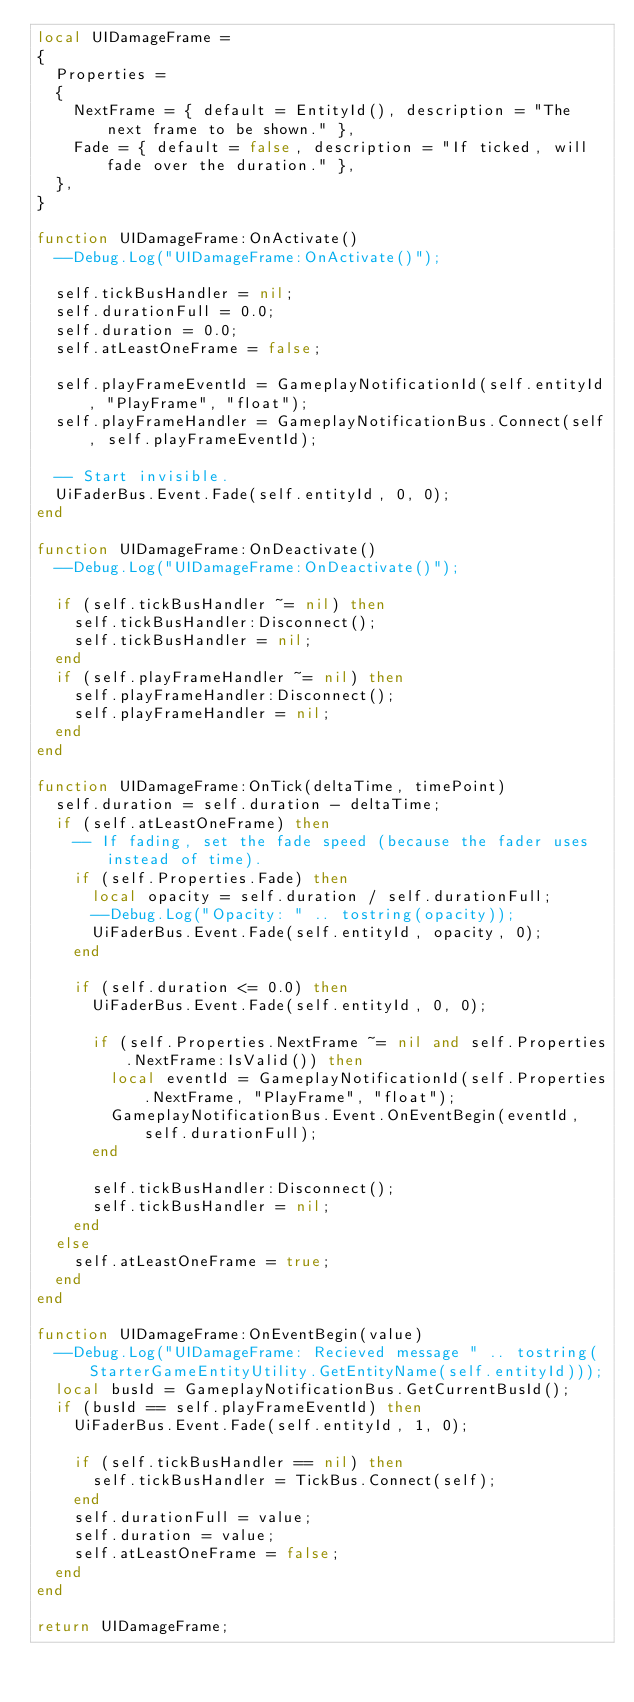Convert code to text. <code><loc_0><loc_0><loc_500><loc_500><_Lua_>local UIDamageFrame =
{
	Properties =
	{
		NextFrame = { default = EntityId(), description = "The next frame to be shown." },
		Fade = { default = false, description = "If ticked, will fade over the duration." },
	},
}

function UIDamageFrame:OnActivate()
	--Debug.Log("UIDamageFrame:OnActivate()");
	
	self.tickBusHandler = nil;
	self.durationFull = 0.0;
	self.duration = 0.0;
	self.atLeastOneFrame = false;
	
	self.playFrameEventId = GameplayNotificationId(self.entityId, "PlayFrame", "float");
	self.playFrameHandler = GameplayNotificationBus.Connect(self, self.playFrameEventId);
	
	-- Start invisible.
	UiFaderBus.Event.Fade(self.entityId, 0, 0);
end

function UIDamageFrame:OnDeactivate()
	--Debug.Log("UIDamageFrame:OnDeactivate()");
	
	if (self.tickBusHandler ~= nil) then
		self.tickBusHandler:Disconnect();
		self.tickBusHandler = nil;
	end
	if (self.playFrameHandler ~= nil) then
		self.playFrameHandler:Disconnect();
		self.playFrameHandler = nil;
	end
end

function UIDamageFrame:OnTick(deltaTime, timePoint)
	self.duration = self.duration - deltaTime;
	if (self.atLeastOneFrame) then
		-- If fading, set the fade speed (because the fader uses instead of time).
		if (self.Properties.Fade) then
			local opacity = self.duration / self.durationFull;
			--Debug.Log("Opacity: " .. tostring(opacity));
			UiFaderBus.Event.Fade(self.entityId, opacity, 0);
		end
		
		if (self.duration <= 0.0) then
			UiFaderBus.Event.Fade(self.entityId, 0, 0);
			
			if (self.Properties.NextFrame ~= nil and self.Properties.NextFrame:IsValid()) then
				local eventId = GameplayNotificationId(self.Properties.NextFrame, "PlayFrame", "float");
				GameplayNotificationBus.Event.OnEventBegin(eventId, self.durationFull);
			end
			
			self.tickBusHandler:Disconnect();
			self.tickBusHandler = nil;
		end
	else
		self.atLeastOneFrame = true;
	end
end

function UIDamageFrame:OnEventBegin(value)
	--Debug.Log("UIDamageFrame: Recieved message " .. tostring(StarterGameEntityUtility.GetEntityName(self.entityId)));
	local busId = GameplayNotificationBus.GetCurrentBusId();
	if (busId == self.playFrameEventId) then
		UiFaderBus.Event.Fade(self.entityId, 1, 0);
		
		if (self.tickBusHandler == nil) then
			self.tickBusHandler = TickBus.Connect(self);
		end
		self.durationFull = value;
		self.duration = value;
		self.atLeastOneFrame = false;
	end
end

return UIDamageFrame;
</code> 